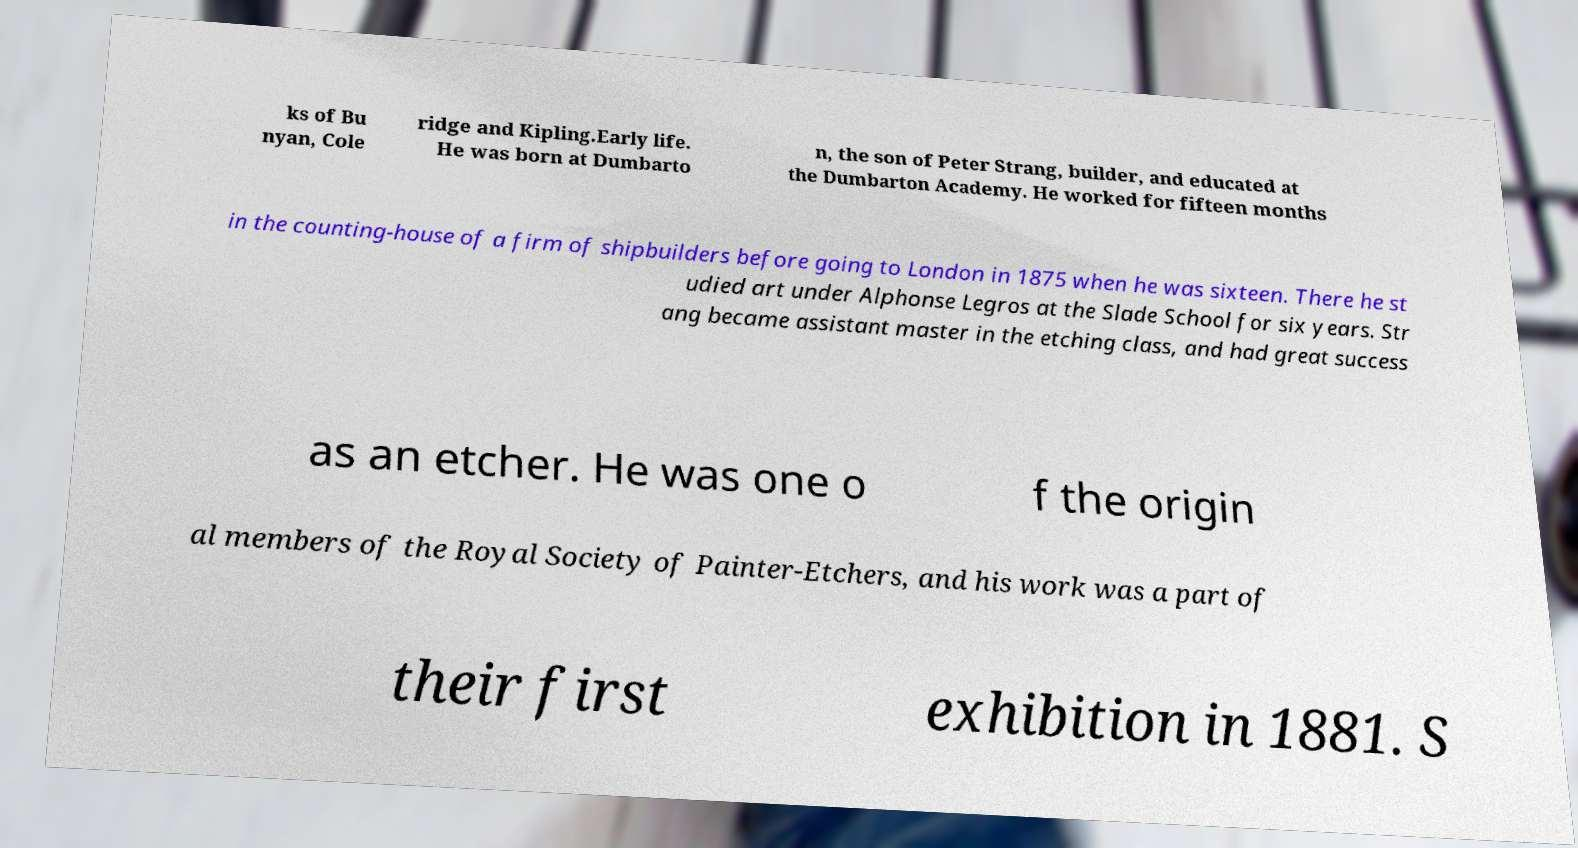Can you accurately transcribe the text from the provided image for me? ks of Bu nyan, Cole ridge and Kipling.Early life. He was born at Dumbarto n, the son of Peter Strang, builder, and educated at the Dumbarton Academy. He worked for fifteen months in the counting-house of a firm of shipbuilders before going to London in 1875 when he was sixteen. There he st udied art under Alphonse Legros at the Slade School for six years. Str ang became assistant master in the etching class, and had great success as an etcher. He was one o f the origin al members of the Royal Society of Painter-Etchers, and his work was a part of their first exhibition in 1881. S 